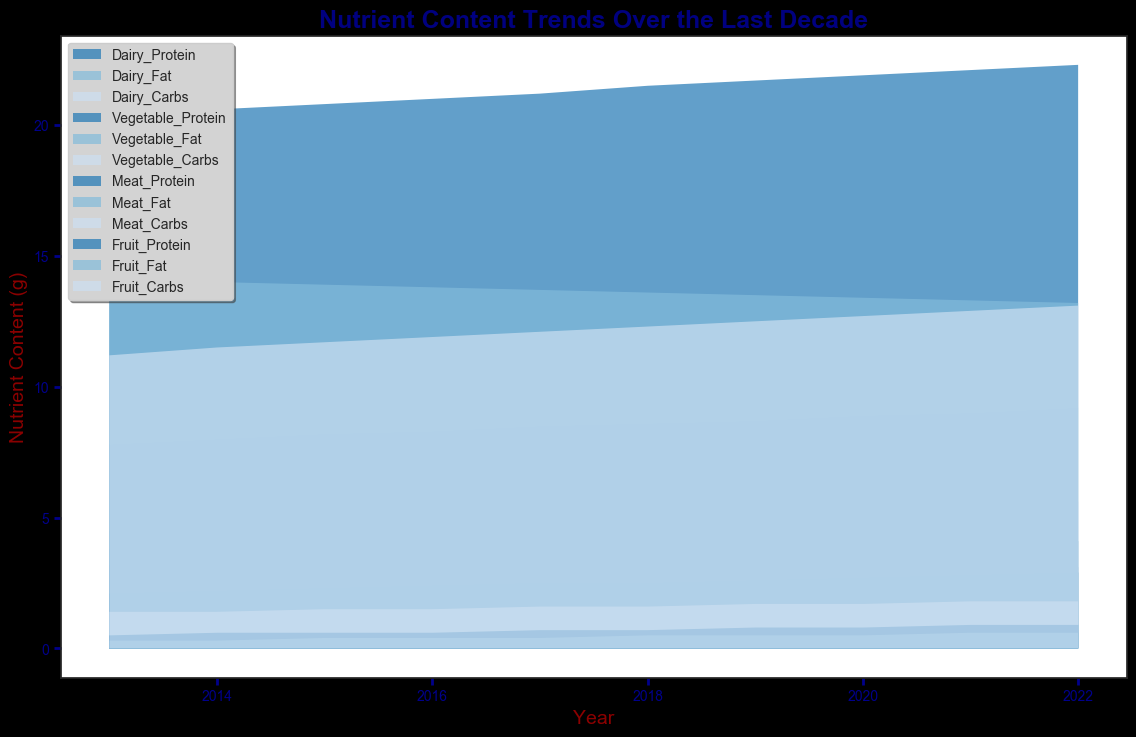What's the trend of Dairy Protein content across the decade? Look at the section of the plot corresponding to Dairy Protein. Notice the overall upward slope from 3.2g in 2013 to 4.1g in 2022, indicating an increase.
Answer: Increasing Which food group shows the largest increase in Carbs content over the decade? Compare the change in Carbs content in Dairy, Vegetable, Meat, and Fruit groups. Dairy Carbs increased from 4.5g to 5.6g, Vegetable Carbs from 7.8g to 9.2g, Meat Carbs from 1.4g to 1.8g, and Fruit Carbs from 11.2g to 13.1g. Fruit Carbs has the largest change.
Answer: Fruit By 2021, which nutrient in Meat had the least content? Refer to the nutrient contents for Meat in 2021. Meat Carbs had 1.8g, which is less than Meat Protein (22.1g) and Meat Fat (13.3g).
Answer: Carbs Compare the Carbs content trend between Dairy and Vegetable groups. Which group shows a higher overall increase? Examine the Carbs content for Dairy and Vegetables across the years. Dairy Carbs went from 4.5g to 5.6g, an increase of 1.1g. Vegetable Carbs went from 7.8g to 9.2g, an increase of 1.4g. Vegetables show a higher increase.
Answer: Vegetables What is the average content of Vegetable Protein across the decade? Add the Vegetable Protein contents from each year (2.1, 2.2, 2.3, 2.4, 2.5, 2.5, 2.6, 2.7, 2.8, 2.9) and divide by the number of years (10). Sum is 25.0, so the average is 25.0/10 = 2.5
Answer: 2.5 Which year did Dairy Fat content see the largest single-year drop? Compare yearly changes in Dairy Fat content from 2013 to 2022. The largest drop is between 2013 (3.8g) and 2014 (3.7g), a decrease by 0.1g, the only visible drop in this period.
Answer: 2014 For the year 2020, which group and nutrient had the highest content? Compare all nutrients across groups in 2020. Meat Protein had 21.9g, which is higher than all other nutrients for any group in that year.
Answer: Meat Protein Calculate the total Carbs content for all food groups in 2018. Sum the Carbs content from Dairy (5.1g), Vegetables (8.6g), Meat (1.6g), and Fruit (12.3g) for 2018. The sum is 5.1 + 8.6 + 1.6 + 12.3 = 27.6g
Answer: 27.6 Which nutrient exhibited the least variance over the decade? Evaluate the visual consistency of nutrient areas. Dairy Fat (ranging 3.1g-3.8g) appears to vary less compared to others (like Carbs in Fruits).
Answer: Dairy Fat 